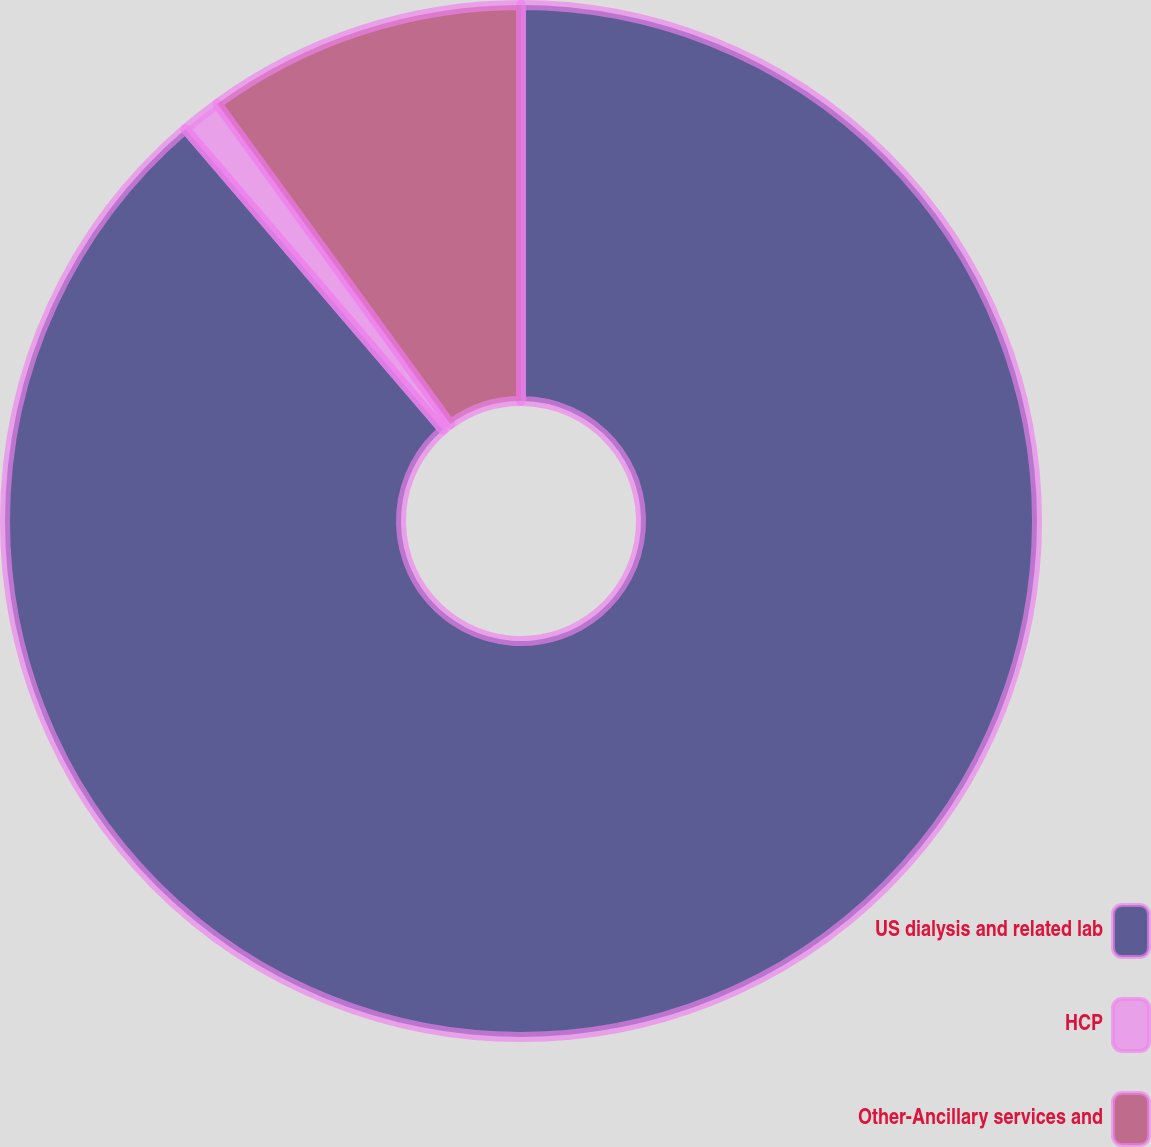Convert chart to OTSL. <chart><loc_0><loc_0><loc_500><loc_500><pie_chart><fcel>US dialysis and related lab<fcel>HCP<fcel>Other-Ancillary services and<nl><fcel>88.73%<fcel>1.26%<fcel>10.01%<nl></chart> 